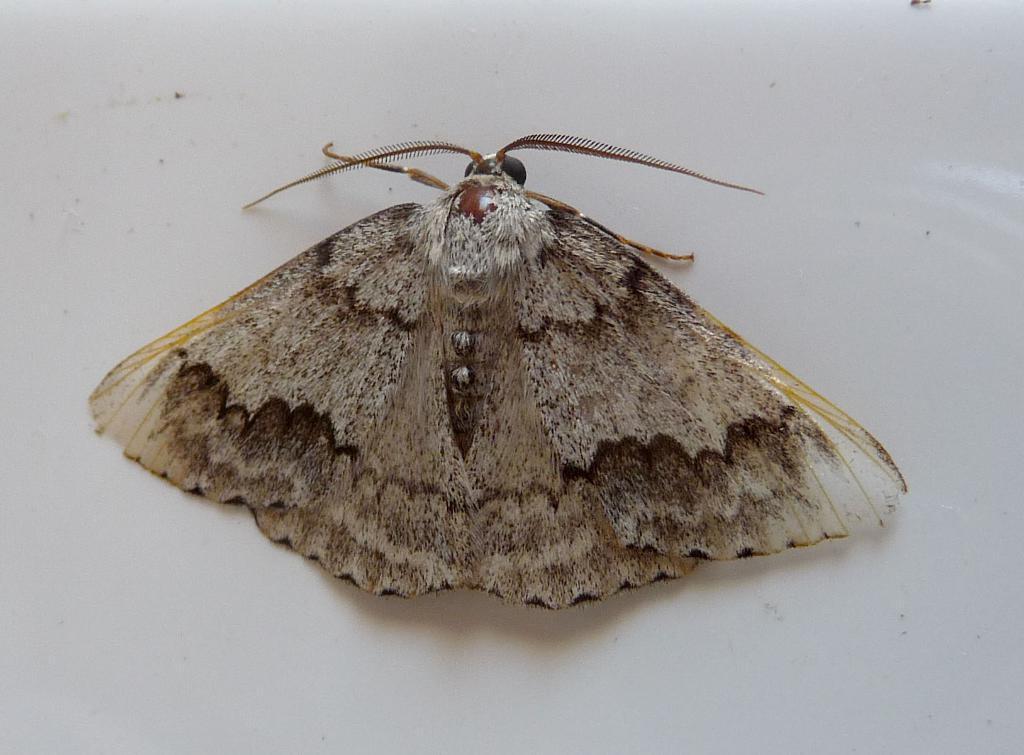Could you give a brief overview of what you see in this image? In this image, we can see brown house moth on the white surface. 